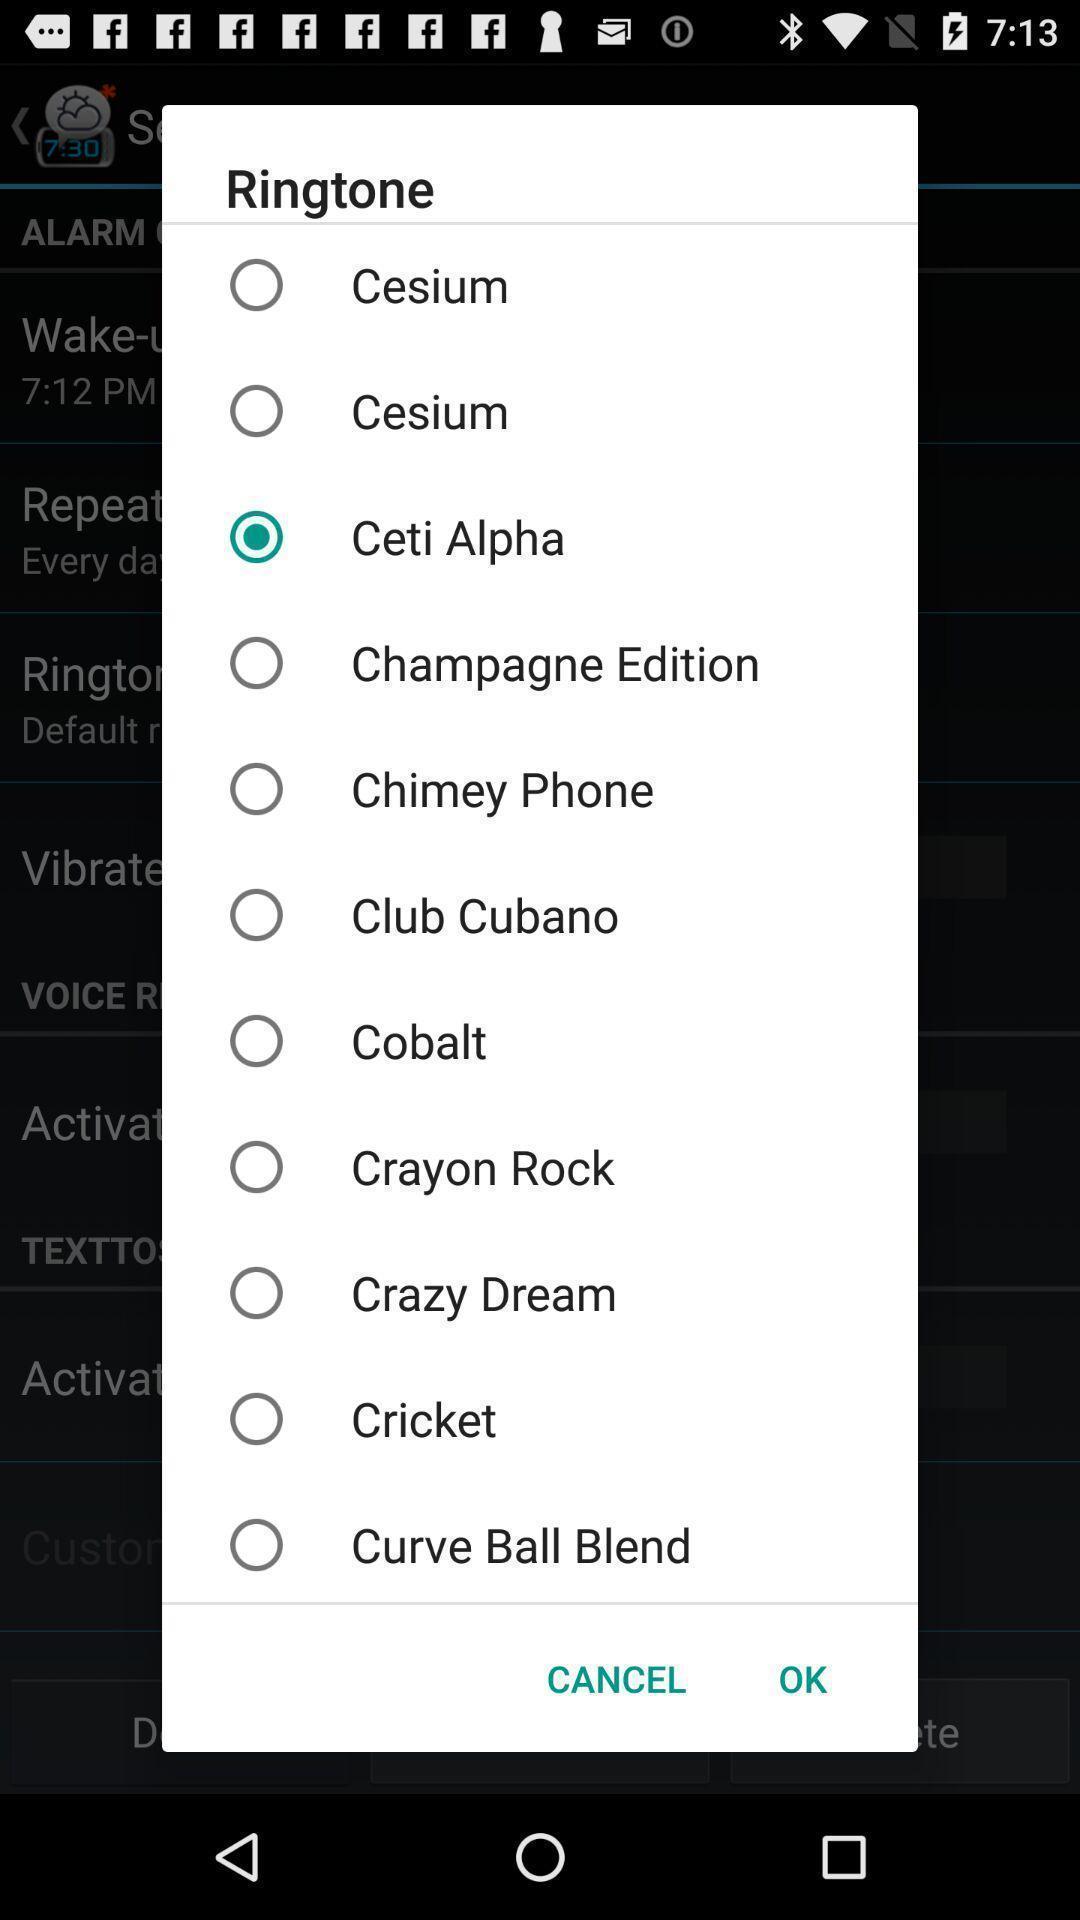What details can you identify in this image? Pop up page for choosing a ringtone. 